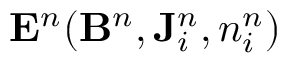<formula> <loc_0><loc_0><loc_500><loc_500>{ E } ^ { n } ( { B } ^ { n } , { J } _ { i } ^ { n } , n _ { i } ^ { n } )</formula> 